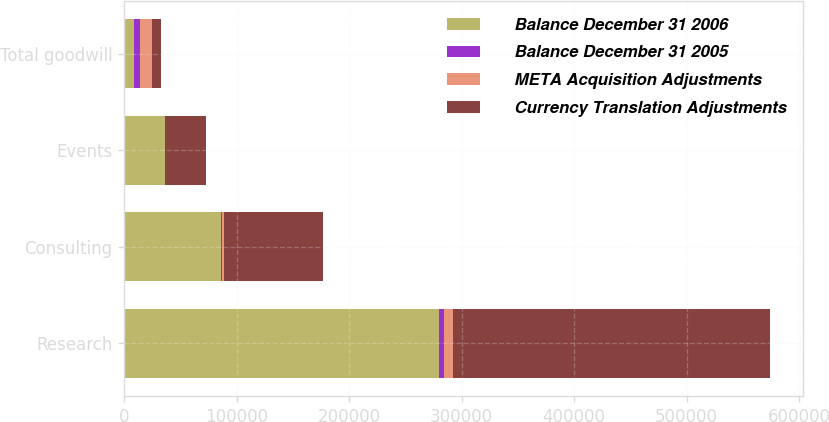Convert chart to OTSL. <chart><loc_0><loc_0><loc_500><loc_500><stacked_bar_chart><ecel><fcel>Research<fcel>Consulting<fcel>Events<fcel>Total goodwill<nl><fcel>Balance December 31 2006<fcel>279500<fcel>86086<fcel>36366<fcel>8841.5<nl><fcel>Balance December 31 2005<fcel>4698<fcel>631<fcel>178<fcel>5507<nl><fcel>META Acquisition Adjustments<fcel>7665<fcel>2211<fcel>142<fcel>10018<nl><fcel>Currency Translation Adjustments<fcel>282467<fcel>87666<fcel>36330<fcel>8841.5<nl></chart> 